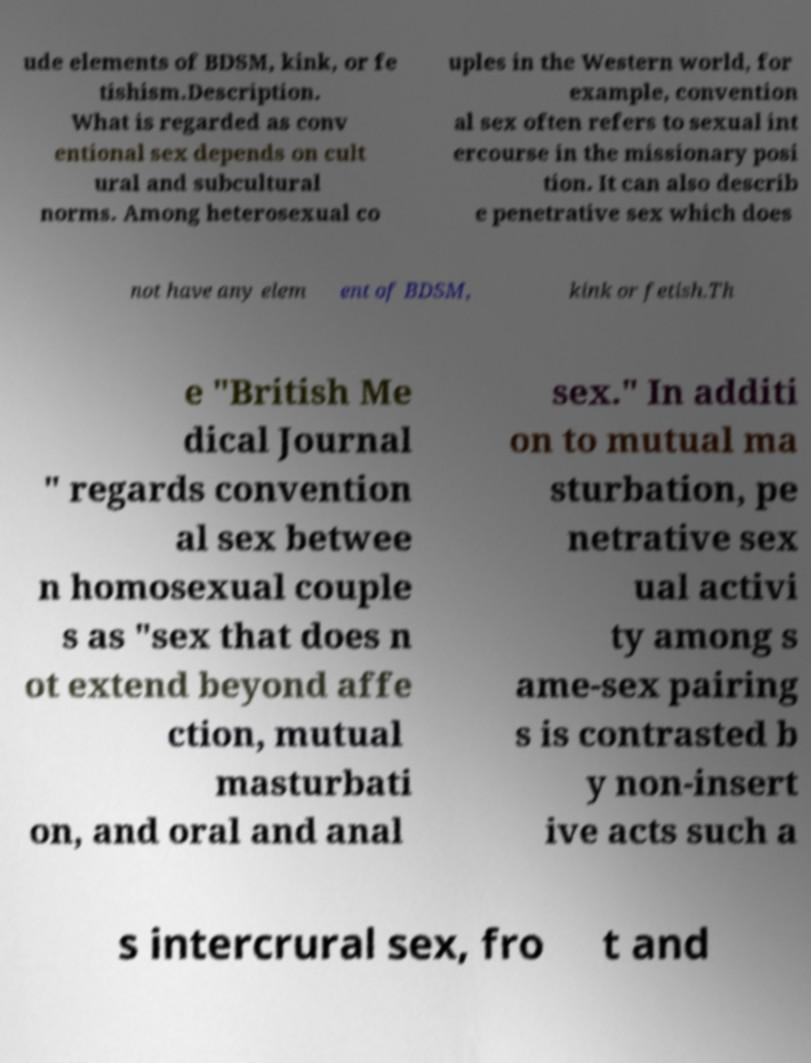For documentation purposes, I need the text within this image transcribed. Could you provide that? ude elements of BDSM, kink, or fe tishism.Description. What is regarded as conv entional sex depends on cult ural and subcultural norms. Among heterosexual co uples in the Western world, for example, convention al sex often refers to sexual int ercourse in the missionary posi tion. It can also describ e penetrative sex which does not have any elem ent of BDSM, kink or fetish.Th e "British Me dical Journal " regards convention al sex betwee n homosexual couple s as "sex that does n ot extend beyond affe ction, mutual masturbati on, and oral and anal sex." In additi on to mutual ma sturbation, pe netrative sex ual activi ty among s ame-sex pairing s is contrasted b y non-insert ive acts such a s intercrural sex, fro t and 